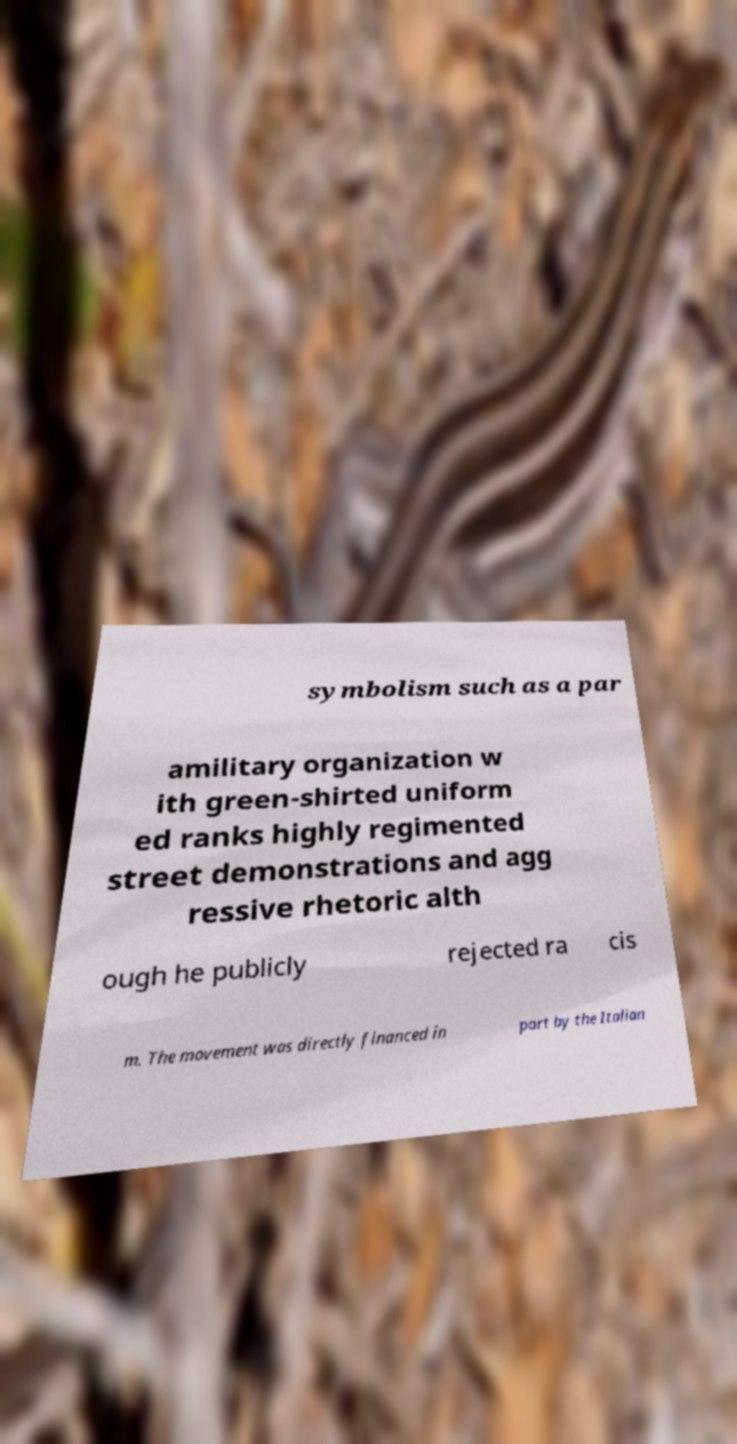Can you read and provide the text displayed in the image?This photo seems to have some interesting text. Can you extract and type it out for me? symbolism such as a par amilitary organization w ith green-shirted uniform ed ranks highly regimented street demonstrations and agg ressive rhetoric alth ough he publicly rejected ra cis m. The movement was directly financed in part by the Italian 